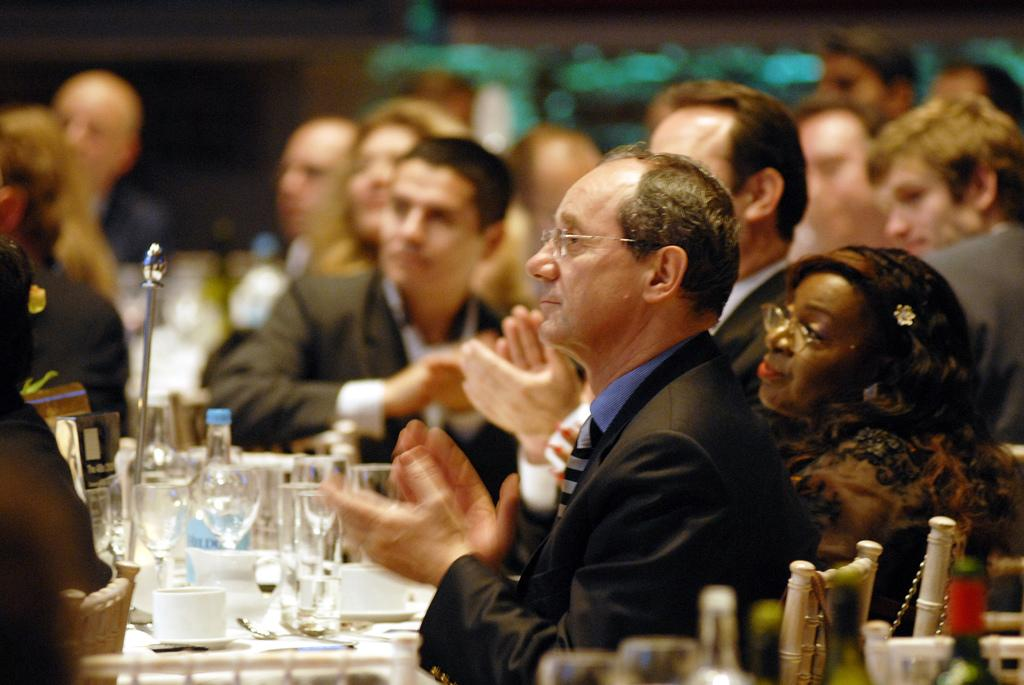What are the people in the image doing? The people in the image are sitting on chairs. Can you describe the appearance of any of the people in the image? Two people are wearing glasses. What type of objects can be seen in the image besides the people? There are glasses, bottles, cups, and saucers visible in the image. How would you describe the background of the image? The background appears blurry. How many dimes are visible on the table in the image? There are no dimes visible on the table in the image. Are any of the people in the image pointing their fingers at something? There is no indication in the image that any of the people are pointing their fingers at anything. 